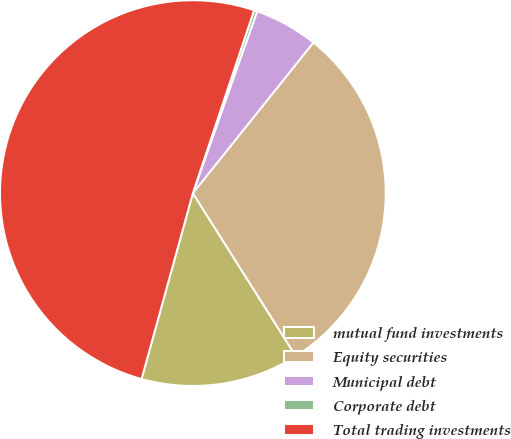<chart> <loc_0><loc_0><loc_500><loc_500><pie_chart><fcel>mutual fund investments<fcel>Equity securities<fcel>Municipal debt<fcel>Corporate debt<fcel>Total trading investments<nl><fcel>13.25%<fcel>30.29%<fcel>5.33%<fcel>0.27%<fcel>50.85%<nl></chart> 